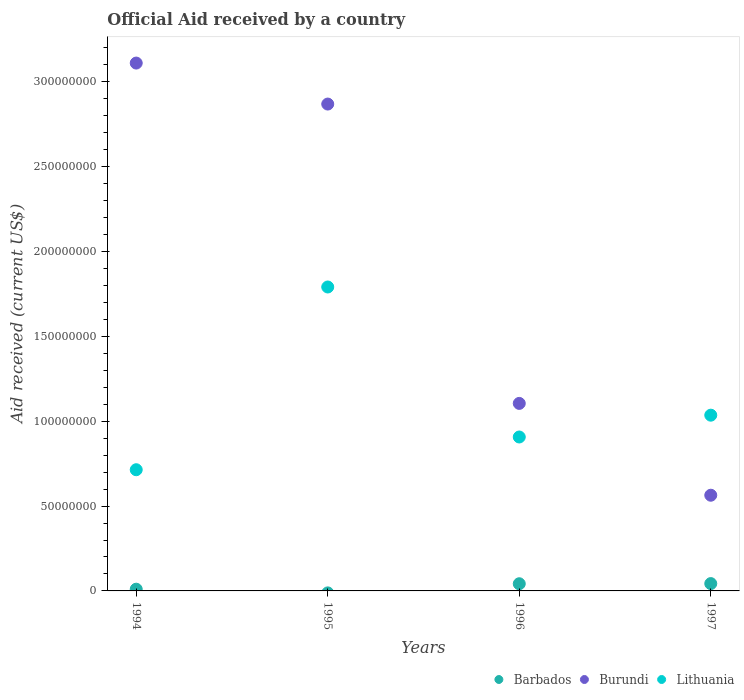What is the net official aid received in Burundi in 1995?
Provide a succinct answer. 2.87e+08. Across all years, what is the maximum net official aid received in Barbados?
Ensure brevity in your answer.  4.32e+06. Across all years, what is the minimum net official aid received in Burundi?
Ensure brevity in your answer.  5.64e+07. What is the total net official aid received in Lithuania in the graph?
Provide a succinct answer. 4.45e+08. What is the difference between the net official aid received in Burundi in 1994 and that in 1997?
Keep it short and to the point. 2.55e+08. What is the difference between the net official aid received in Barbados in 1995 and the net official aid received in Lithuania in 1996?
Offer a terse response. -9.07e+07. What is the average net official aid received in Barbados per year?
Provide a short and direct response. 2.39e+06. In the year 1994, what is the difference between the net official aid received in Burundi and net official aid received in Barbados?
Offer a very short reply. 3.10e+08. What is the ratio of the net official aid received in Burundi in 1995 to that in 1997?
Give a very brief answer. 5.09. Is the difference between the net official aid received in Burundi in 1994 and 1996 greater than the difference between the net official aid received in Barbados in 1994 and 1996?
Provide a short and direct response. Yes. What is the difference between the highest and the lowest net official aid received in Barbados?
Keep it short and to the point. 4.32e+06. In how many years, is the net official aid received in Burundi greater than the average net official aid received in Burundi taken over all years?
Keep it short and to the point. 2. Is the sum of the net official aid received in Burundi in 1995 and 1997 greater than the maximum net official aid received in Lithuania across all years?
Offer a terse response. Yes. Is it the case that in every year, the sum of the net official aid received in Barbados and net official aid received in Lithuania  is greater than the net official aid received in Burundi?
Offer a terse response. No. Does the net official aid received in Lithuania monotonically increase over the years?
Provide a short and direct response. No. Is the net official aid received in Burundi strictly greater than the net official aid received in Lithuania over the years?
Offer a very short reply. No. Is the net official aid received in Burundi strictly less than the net official aid received in Lithuania over the years?
Provide a short and direct response. No. How many dotlines are there?
Your answer should be very brief. 3. Does the graph contain any zero values?
Give a very brief answer. Yes. Where does the legend appear in the graph?
Provide a succinct answer. Bottom right. How many legend labels are there?
Your answer should be compact. 3. How are the legend labels stacked?
Ensure brevity in your answer.  Horizontal. What is the title of the graph?
Make the answer very short. Official Aid received by a country. What is the label or title of the X-axis?
Offer a terse response. Years. What is the label or title of the Y-axis?
Ensure brevity in your answer.  Aid received (current US$). What is the Aid received (current US$) in Barbados in 1994?
Give a very brief answer. 1.02e+06. What is the Aid received (current US$) in Burundi in 1994?
Give a very brief answer. 3.11e+08. What is the Aid received (current US$) of Lithuania in 1994?
Your answer should be very brief. 7.14e+07. What is the Aid received (current US$) in Barbados in 1995?
Make the answer very short. 0. What is the Aid received (current US$) in Burundi in 1995?
Ensure brevity in your answer.  2.87e+08. What is the Aid received (current US$) in Lithuania in 1995?
Provide a short and direct response. 1.79e+08. What is the Aid received (current US$) in Barbados in 1996?
Give a very brief answer. 4.23e+06. What is the Aid received (current US$) in Burundi in 1996?
Your answer should be compact. 1.11e+08. What is the Aid received (current US$) in Lithuania in 1996?
Offer a terse response. 9.07e+07. What is the Aid received (current US$) of Barbados in 1997?
Keep it short and to the point. 4.32e+06. What is the Aid received (current US$) in Burundi in 1997?
Make the answer very short. 5.64e+07. What is the Aid received (current US$) in Lithuania in 1997?
Your response must be concise. 1.04e+08. Across all years, what is the maximum Aid received (current US$) of Barbados?
Provide a succinct answer. 4.32e+06. Across all years, what is the maximum Aid received (current US$) in Burundi?
Offer a terse response. 3.11e+08. Across all years, what is the maximum Aid received (current US$) in Lithuania?
Your response must be concise. 1.79e+08. Across all years, what is the minimum Aid received (current US$) of Burundi?
Your answer should be compact. 5.64e+07. Across all years, what is the minimum Aid received (current US$) of Lithuania?
Your response must be concise. 7.14e+07. What is the total Aid received (current US$) in Barbados in the graph?
Make the answer very short. 9.57e+06. What is the total Aid received (current US$) of Burundi in the graph?
Offer a very short reply. 7.65e+08. What is the total Aid received (current US$) in Lithuania in the graph?
Ensure brevity in your answer.  4.45e+08. What is the difference between the Aid received (current US$) in Burundi in 1994 and that in 1995?
Keep it short and to the point. 2.42e+07. What is the difference between the Aid received (current US$) in Lithuania in 1994 and that in 1995?
Ensure brevity in your answer.  -1.08e+08. What is the difference between the Aid received (current US$) in Barbados in 1994 and that in 1996?
Your answer should be very brief. -3.21e+06. What is the difference between the Aid received (current US$) of Burundi in 1994 and that in 1996?
Your answer should be very brief. 2.01e+08. What is the difference between the Aid received (current US$) in Lithuania in 1994 and that in 1996?
Offer a terse response. -1.93e+07. What is the difference between the Aid received (current US$) of Barbados in 1994 and that in 1997?
Give a very brief answer. -3.30e+06. What is the difference between the Aid received (current US$) of Burundi in 1994 and that in 1997?
Ensure brevity in your answer.  2.55e+08. What is the difference between the Aid received (current US$) of Lithuania in 1994 and that in 1997?
Keep it short and to the point. -3.22e+07. What is the difference between the Aid received (current US$) of Burundi in 1995 and that in 1996?
Your answer should be very brief. 1.76e+08. What is the difference between the Aid received (current US$) in Lithuania in 1995 and that in 1996?
Ensure brevity in your answer.  8.84e+07. What is the difference between the Aid received (current US$) in Burundi in 1995 and that in 1997?
Make the answer very short. 2.31e+08. What is the difference between the Aid received (current US$) of Lithuania in 1995 and that in 1997?
Provide a succinct answer. 7.56e+07. What is the difference between the Aid received (current US$) in Barbados in 1996 and that in 1997?
Ensure brevity in your answer.  -9.00e+04. What is the difference between the Aid received (current US$) in Burundi in 1996 and that in 1997?
Offer a terse response. 5.41e+07. What is the difference between the Aid received (current US$) in Lithuania in 1996 and that in 1997?
Offer a terse response. -1.29e+07. What is the difference between the Aid received (current US$) of Barbados in 1994 and the Aid received (current US$) of Burundi in 1995?
Your answer should be compact. -2.86e+08. What is the difference between the Aid received (current US$) in Barbados in 1994 and the Aid received (current US$) in Lithuania in 1995?
Offer a terse response. -1.78e+08. What is the difference between the Aid received (current US$) in Burundi in 1994 and the Aid received (current US$) in Lithuania in 1995?
Your answer should be compact. 1.32e+08. What is the difference between the Aid received (current US$) of Barbados in 1994 and the Aid received (current US$) of Burundi in 1996?
Provide a succinct answer. -1.10e+08. What is the difference between the Aid received (current US$) in Barbados in 1994 and the Aid received (current US$) in Lithuania in 1996?
Give a very brief answer. -8.97e+07. What is the difference between the Aid received (current US$) in Burundi in 1994 and the Aid received (current US$) in Lithuania in 1996?
Offer a very short reply. 2.20e+08. What is the difference between the Aid received (current US$) of Barbados in 1994 and the Aid received (current US$) of Burundi in 1997?
Your response must be concise. -5.54e+07. What is the difference between the Aid received (current US$) of Barbados in 1994 and the Aid received (current US$) of Lithuania in 1997?
Make the answer very short. -1.03e+08. What is the difference between the Aid received (current US$) of Burundi in 1994 and the Aid received (current US$) of Lithuania in 1997?
Make the answer very short. 2.08e+08. What is the difference between the Aid received (current US$) in Burundi in 1995 and the Aid received (current US$) in Lithuania in 1996?
Offer a very short reply. 1.96e+08. What is the difference between the Aid received (current US$) in Burundi in 1995 and the Aid received (current US$) in Lithuania in 1997?
Provide a succinct answer. 1.83e+08. What is the difference between the Aid received (current US$) of Barbados in 1996 and the Aid received (current US$) of Burundi in 1997?
Provide a succinct answer. -5.22e+07. What is the difference between the Aid received (current US$) in Barbados in 1996 and the Aid received (current US$) in Lithuania in 1997?
Make the answer very short. -9.94e+07. What is the difference between the Aid received (current US$) of Burundi in 1996 and the Aid received (current US$) of Lithuania in 1997?
Make the answer very short. 6.94e+06. What is the average Aid received (current US$) in Barbados per year?
Make the answer very short. 2.39e+06. What is the average Aid received (current US$) in Burundi per year?
Offer a terse response. 1.91e+08. What is the average Aid received (current US$) of Lithuania per year?
Your answer should be compact. 1.11e+08. In the year 1994, what is the difference between the Aid received (current US$) of Barbados and Aid received (current US$) of Burundi?
Your response must be concise. -3.10e+08. In the year 1994, what is the difference between the Aid received (current US$) of Barbados and Aid received (current US$) of Lithuania?
Offer a terse response. -7.04e+07. In the year 1994, what is the difference between the Aid received (current US$) of Burundi and Aid received (current US$) of Lithuania?
Your response must be concise. 2.40e+08. In the year 1995, what is the difference between the Aid received (current US$) in Burundi and Aid received (current US$) in Lithuania?
Make the answer very short. 1.08e+08. In the year 1996, what is the difference between the Aid received (current US$) in Barbados and Aid received (current US$) in Burundi?
Your response must be concise. -1.06e+08. In the year 1996, what is the difference between the Aid received (current US$) in Barbados and Aid received (current US$) in Lithuania?
Provide a succinct answer. -8.65e+07. In the year 1996, what is the difference between the Aid received (current US$) in Burundi and Aid received (current US$) in Lithuania?
Your answer should be compact. 1.98e+07. In the year 1997, what is the difference between the Aid received (current US$) in Barbados and Aid received (current US$) in Burundi?
Provide a succinct answer. -5.21e+07. In the year 1997, what is the difference between the Aid received (current US$) in Barbados and Aid received (current US$) in Lithuania?
Provide a short and direct response. -9.93e+07. In the year 1997, what is the difference between the Aid received (current US$) of Burundi and Aid received (current US$) of Lithuania?
Offer a very short reply. -4.72e+07. What is the ratio of the Aid received (current US$) of Burundi in 1994 to that in 1995?
Provide a short and direct response. 1.08. What is the ratio of the Aid received (current US$) of Lithuania in 1994 to that in 1995?
Provide a short and direct response. 0.4. What is the ratio of the Aid received (current US$) in Barbados in 1994 to that in 1996?
Offer a terse response. 0.24. What is the ratio of the Aid received (current US$) of Burundi in 1994 to that in 1996?
Your answer should be very brief. 2.81. What is the ratio of the Aid received (current US$) in Lithuania in 1994 to that in 1996?
Your answer should be very brief. 0.79. What is the ratio of the Aid received (current US$) in Barbados in 1994 to that in 1997?
Ensure brevity in your answer.  0.24. What is the ratio of the Aid received (current US$) in Burundi in 1994 to that in 1997?
Keep it short and to the point. 5.52. What is the ratio of the Aid received (current US$) in Lithuania in 1994 to that in 1997?
Your answer should be very brief. 0.69. What is the ratio of the Aid received (current US$) in Burundi in 1995 to that in 1996?
Your answer should be compact. 2.6. What is the ratio of the Aid received (current US$) in Lithuania in 1995 to that in 1996?
Offer a very short reply. 1.97. What is the ratio of the Aid received (current US$) of Burundi in 1995 to that in 1997?
Offer a very short reply. 5.09. What is the ratio of the Aid received (current US$) in Lithuania in 1995 to that in 1997?
Provide a succinct answer. 1.73. What is the ratio of the Aid received (current US$) of Barbados in 1996 to that in 1997?
Give a very brief answer. 0.98. What is the ratio of the Aid received (current US$) in Burundi in 1996 to that in 1997?
Ensure brevity in your answer.  1.96. What is the ratio of the Aid received (current US$) in Lithuania in 1996 to that in 1997?
Provide a short and direct response. 0.88. What is the difference between the highest and the second highest Aid received (current US$) in Burundi?
Make the answer very short. 2.42e+07. What is the difference between the highest and the second highest Aid received (current US$) of Lithuania?
Make the answer very short. 7.56e+07. What is the difference between the highest and the lowest Aid received (current US$) in Barbados?
Provide a succinct answer. 4.32e+06. What is the difference between the highest and the lowest Aid received (current US$) of Burundi?
Your answer should be compact. 2.55e+08. What is the difference between the highest and the lowest Aid received (current US$) in Lithuania?
Offer a very short reply. 1.08e+08. 